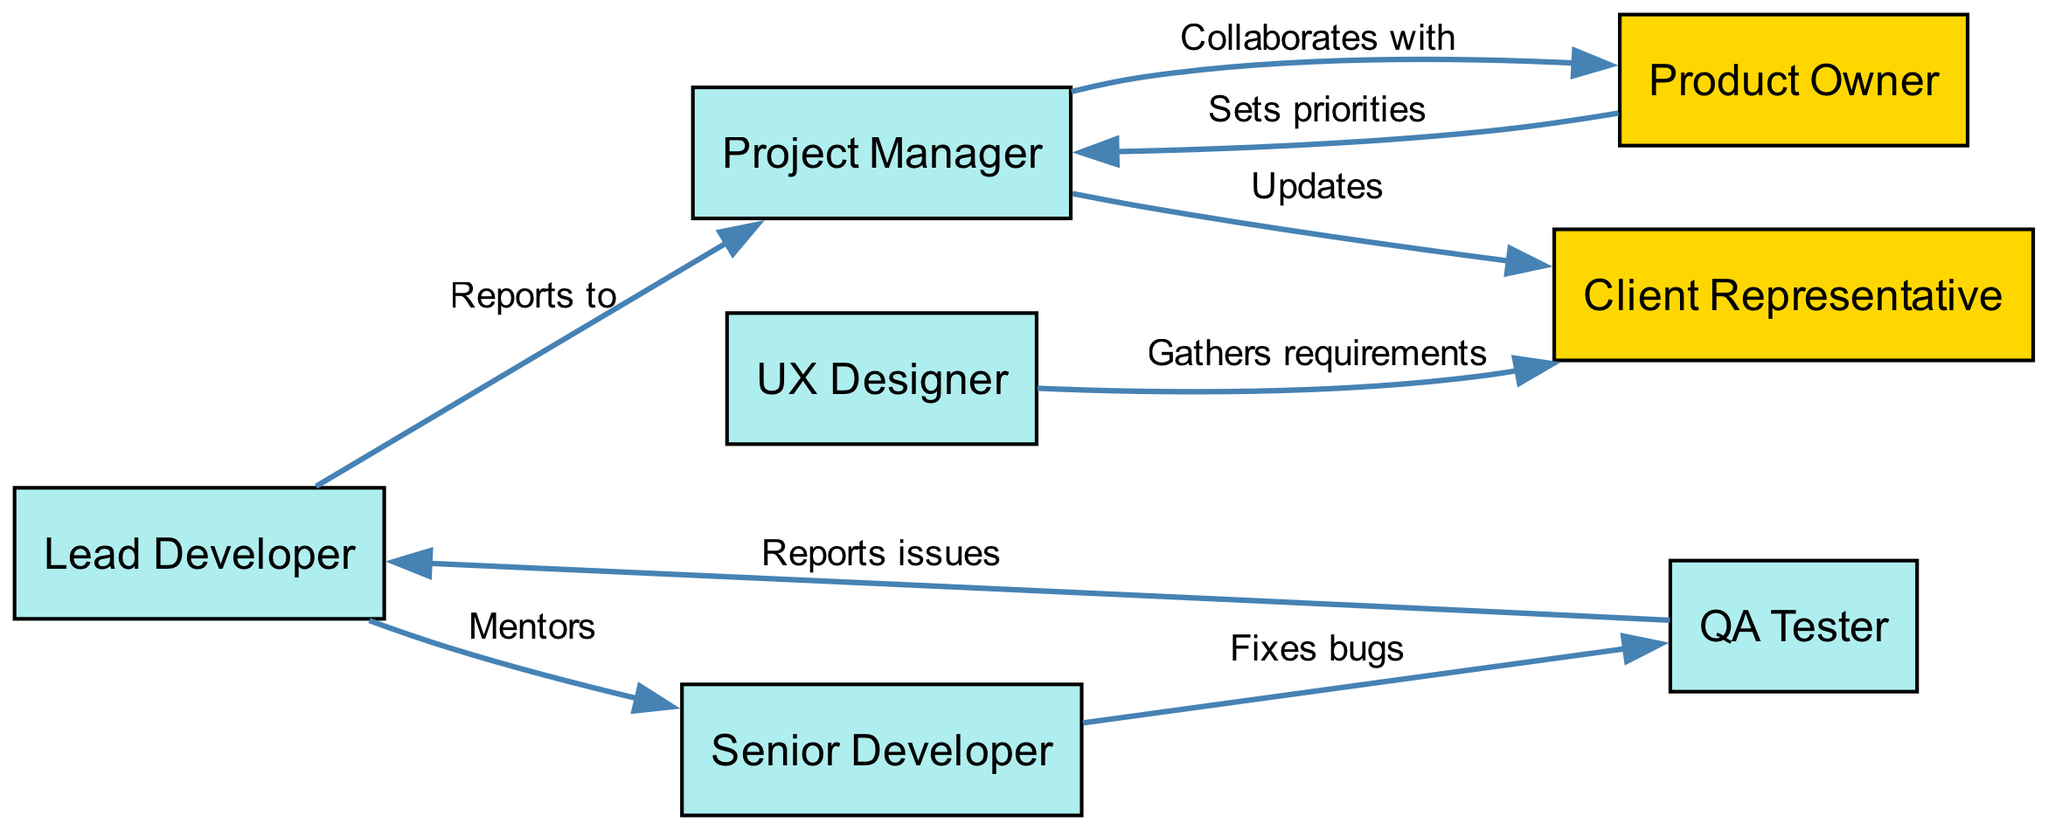What is the role of node 1? Node 1 is labeled as "Lead Developer," which is identified as a team member in the diagram.
Answer: Lead Developer How many stakeholders are represented in the diagram? The diagram includes two nodes labeled as stakeholders: "Client Representative" and "Product Owner."
Answer: 2 Who does the QA Tester report issues to? The QA Tester (node 4) has a direct edge labeled "Reports issues" pointing to the Lead Developer (node 1), indicating their report chain.
Answer: Lead Developer What type of relationship exists between the Project Manager and the Client Representative? There is an edge labeled "Updates" from the Project Manager (node 2) to the Client Representative (node 5), which signifies that the Project Manager is responsible for providing updates to the Client Representative.
Answer: Updates How many edges are there in total in the diagram? To find the total number of edges, we can count each relationship from the data provided. There are eight distinct edges in the diagram.
Answer: 8 Which team member collaborates with the Project Manager? The edge labeled "Collaborates with" indicates that the Product Owner (node 7) is the one who collaborates with the Project Manager (node 2).
Answer: Product Owner What kind of link exists between the Senior Developer and the QA Tester? The connection from Senior Developer (node 6) to QA Tester (node 4) is described by the edge labeled "Fixes bugs," linking their responsibilities in bug resolution.
Answer: Fixes bugs How is the UX Designer involved with the Client Representative? The UX Designer (node 3) gathers requirements from the Client Representative (node 5), indicated by the edge labeled "Gathers requirements," showcasing their direct interaction.
Answer: Gathers requirements 